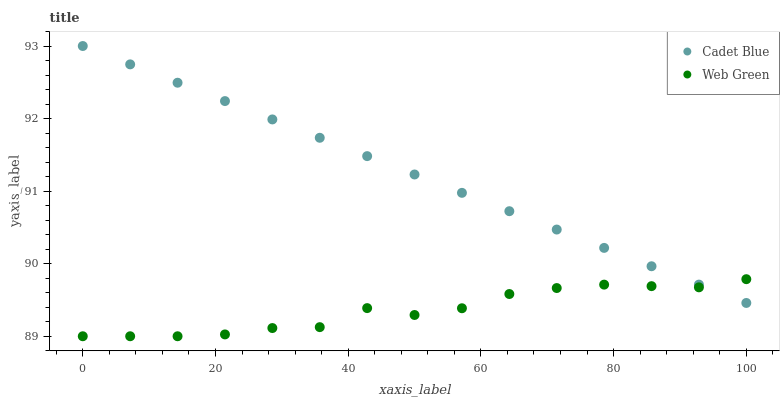Does Web Green have the minimum area under the curve?
Answer yes or no. Yes. Does Cadet Blue have the maximum area under the curve?
Answer yes or no. Yes. Does Web Green have the maximum area under the curve?
Answer yes or no. No. Is Cadet Blue the smoothest?
Answer yes or no. Yes. Is Web Green the roughest?
Answer yes or no. Yes. Is Web Green the smoothest?
Answer yes or no. No. Does Web Green have the lowest value?
Answer yes or no. Yes. Does Cadet Blue have the highest value?
Answer yes or no. Yes. Does Web Green have the highest value?
Answer yes or no. No. Does Web Green intersect Cadet Blue?
Answer yes or no. Yes. Is Web Green less than Cadet Blue?
Answer yes or no. No. Is Web Green greater than Cadet Blue?
Answer yes or no. No. 